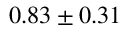<formula> <loc_0><loc_0><loc_500><loc_500>0 . 8 3 \pm 0 . 3 1 \</formula> 